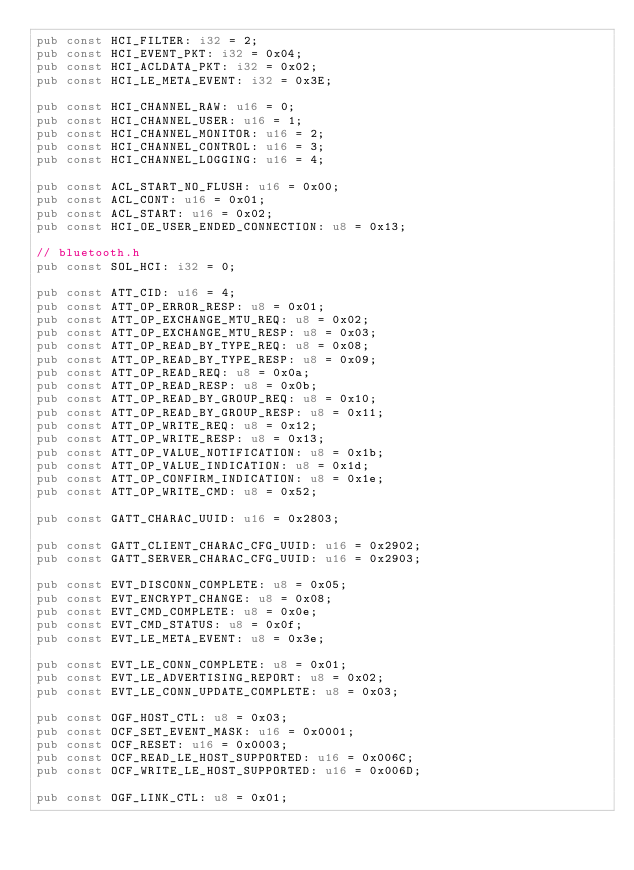<code> <loc_0><loc_0><loc_500><loc_500><_Rust_>pub const HCI_FILTER: i32 = 2;
pub const HCI_EVENT_PKT: i32 = 0x04;
pub const HCI_ACLDATA_PKT: i32 = 0x02;
pub const HCI_LE_META_EVENT: i32 = 0x3E;

pub const HCI_CHANNEL_RAW: u16 = 0;
pub const HCI_CHANNEL_USER: u16 = 1;
pub const HCI_CHANNEL_MONITOR: u16 = 2;
pub const HCI_CHANNEL_CONTROL: u16 = 3;
pub const HCI_CHANNEL_LOGGING: u16 = 4;

pub const ACL_START_NO_FLUSH: u16 = 0x00;
pub const ACL_CONT: u16 = 0x01;
pub const ACL_START: u16 = 0x02;
pub const HCI_OE_USER_ENDED_CONNECTION: u8 = 0x13;

// bluetooth.h
pub const SOL_HCI: i32 = 0;

pub const ATT_CID: u16 = 4;
pub const ATT_OP_ERROR_RESP: u8 = 0x01;
pub const ATT_OP_EXCHANGE_MTU_REQ: u8 = 0x02;
pub const ATT_OP_EXCHANGE_MTU_RESP: u8 = 0x03;
pub const ATT_OP_READ_BY_TYPE_REQ: u8 = 0x08;
pub const ATT_OP_READ_BY_TYPE_RESP: u8 = 0x09;
pub const ATT_OP_READ_REQ: u8 = 0x0a;
pub const ATT_OP_READ_RESP: u8 = 0x0b;
pub const ATT_OP_READ_BY_GROUP_REQ: u8 = 0x10;
pub const ATT_OP_READ_BY_GROUP_RESP: u8 = 0x11;
pub const ATT_OP_WRITE_REQ: u8 = 0x12;
pub const ATT_OP_WRITE_RESP: u8 = 0x13;
pub const ATT_OP_VALUE_NOTIFICATION: u8 = 0x1b;
pub const ATT_OP_VALUE_INDICATION: u8 = 0x1d;
pub const ATT_OP_CONFIRM_INDICATION: u8 = 0x1e;
pub const ATT_OP_WRITE_CMD: u8 = 0x52;

pub const GATT_CHARAC_UUID: u16 = 0x2803;

pub const GATT_CLIENT_CHARAC_CFG_UUID: u16 = 0x2902;
pub const GATT_SERVER_CHARAC_CFG_UUID: u16 = 0x2903;

pub const EVT_DISCONN_COMPLETE: u8 = 0x05;
pub const EVT_ENCRYPT_CHANGE: u8 = 0x08;
pub const EVT_CMD_COMPLETE: u8 = 0x0e;
pub const EVT_CMD_STATUS: u8 = 0x0f;
pub const EVT_LE_META_EVENT: u8 = 0x3e;

pub const EVT_LE_CONN_COMPLETE: u8 = 0x01;
pub const EVT_LE_ADVERTISING_REPORT: u8 = 0x02;
pub const EVT_LE_CONN_UPDATE_COMPLETE: u8 = 0x03;

pub const OGF_HOST_CTL: u8 = 0x03;
pub const OCF_SET_EVENT_MASK: u16 = 0x0001;
pub const OCF_RESET: u16 = 0x0003;
pub const OCF_READ_LE_HOST_SUPPORTED: u16 = 0x006C;
pub const OCF_WRITE_LE_HOST_SUPPORTED: u16 = 0x006D;

pub const OGF_LINK_CTL: u8 = 0x01;</code> 